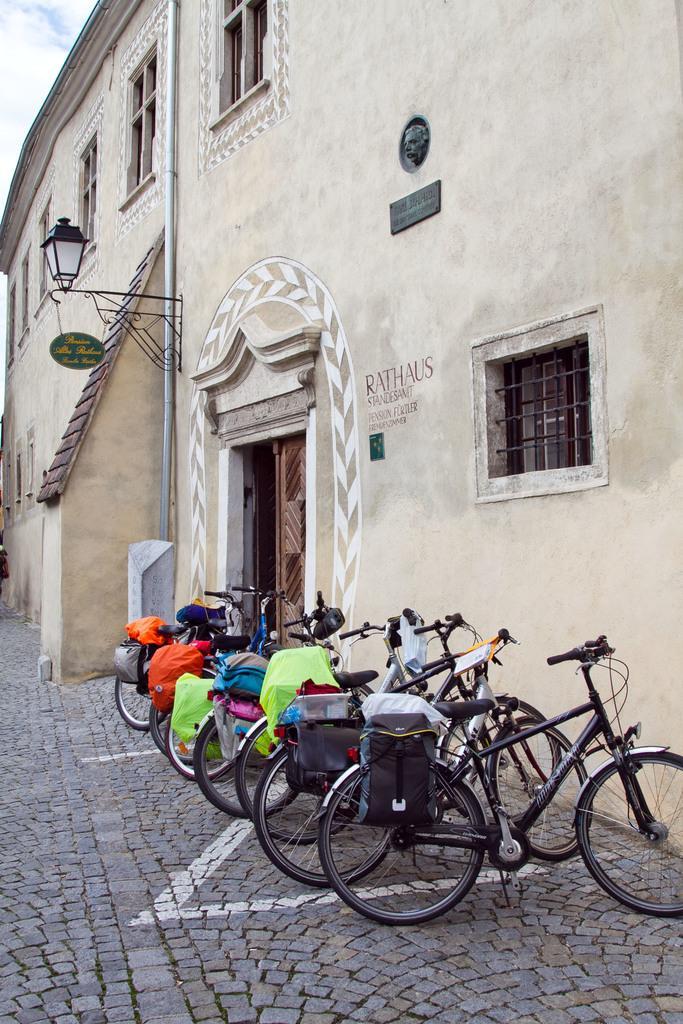In one or two sentences, can you explain what this image depicts? In the picture I can see the building and windows. There is a decorative lamp on the wall of the building. I can see the bicycles parked on the road and there are bags on the carrier of the bicycles. There is a pipeline on the wall. There are clouds in the sky. 